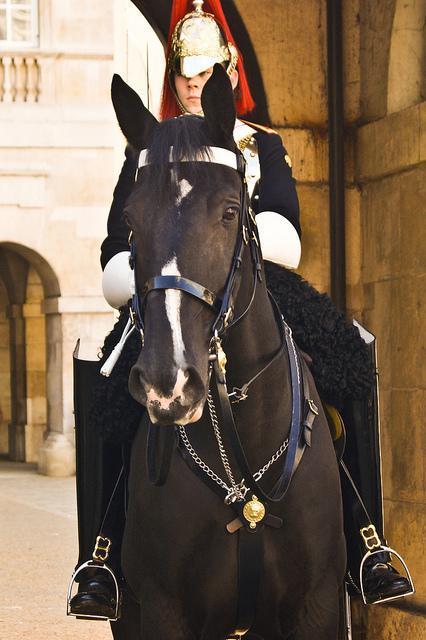How many adult birds are there?
Give a very brief answer. 0. 